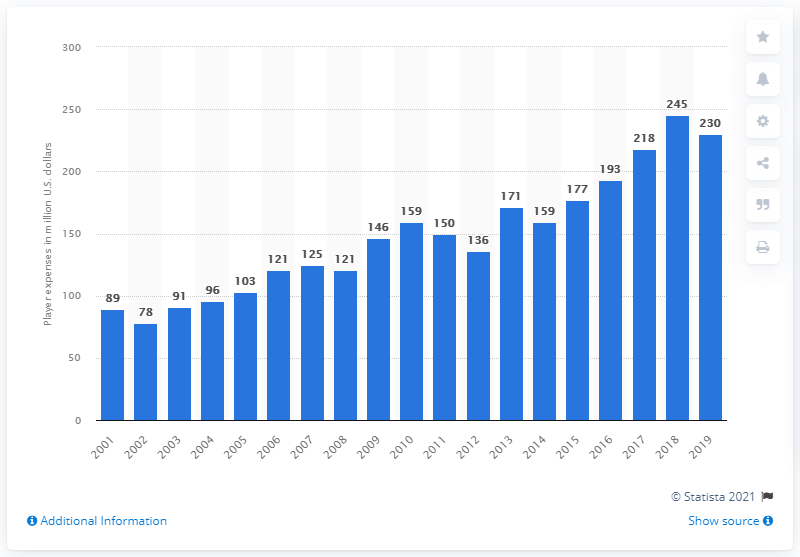Point out several critical features in this image. During the 2019 season, the Green Bay Packers incurred player expenses totaling 230 million dollars. 